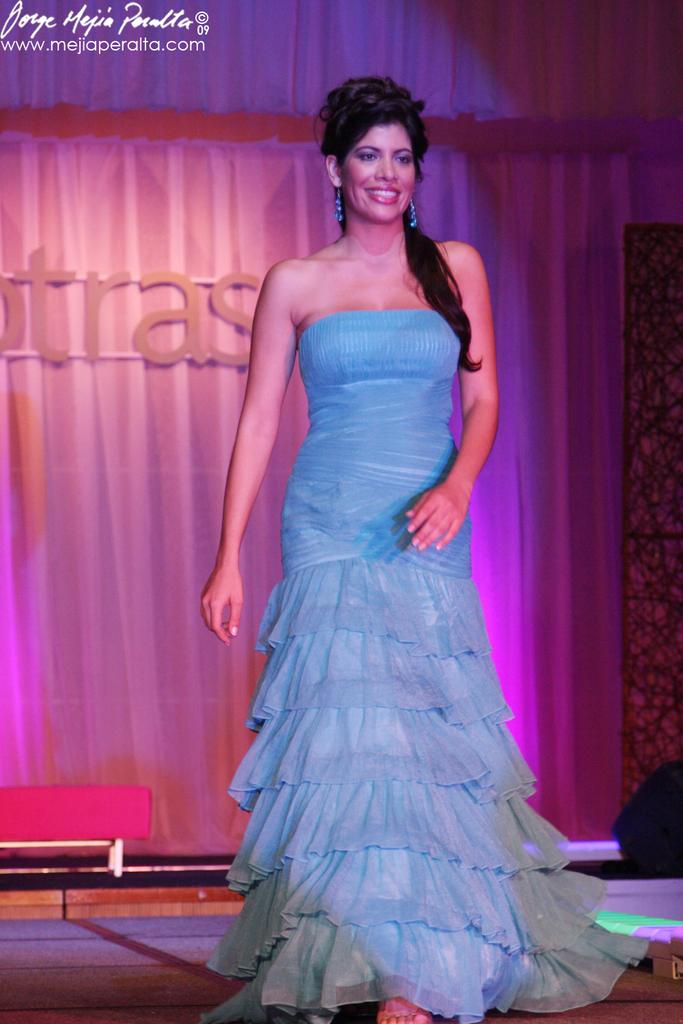What is happening on the stage in the image? There is a person on the stage in the image. What can be seen in the image that provides illumination? There is lighting in the image. What is written or displayed on the wall in the image? There is text on the wall in the image. How many pigs are visible in the image? There are no pigs present in the image. What type of meal is being served on the stage in the image? There is no meal being served in the image; it features a person on the stage. 